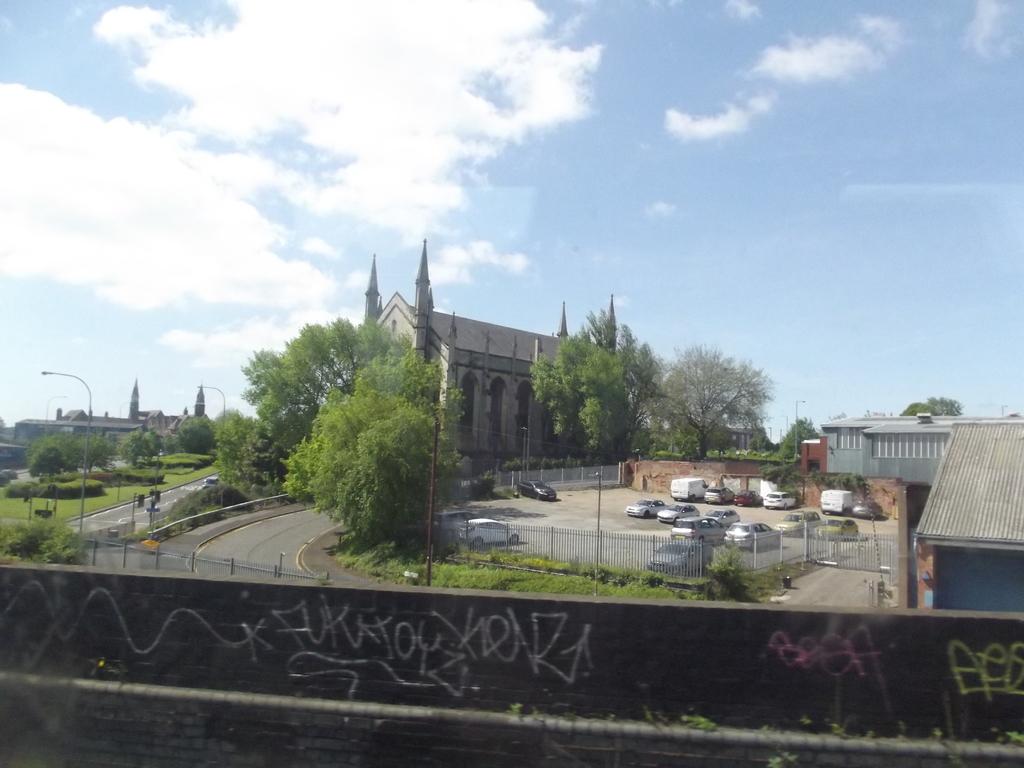How many different colors of graffiti are there?
Your answer should be very brief. Answering does not require reading text in the image. 